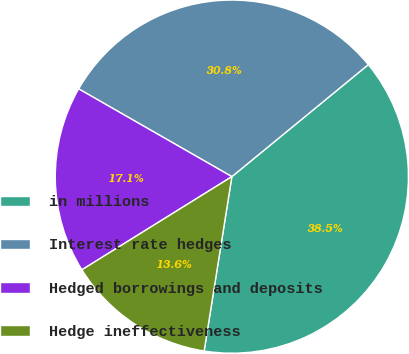Convert chart. <chart><loc_0><loc_0><loc_500><loc_500><pie_chart><fcel>in millions<fcel>Interest rate hedges<fcel>Hedged borrowings and deposits<fcel>Hedge ineffectiveness<nl><fcel>38.45%<fcel>30.78%<fcel>17.13%<fcel>13.64%<nl></chart> 